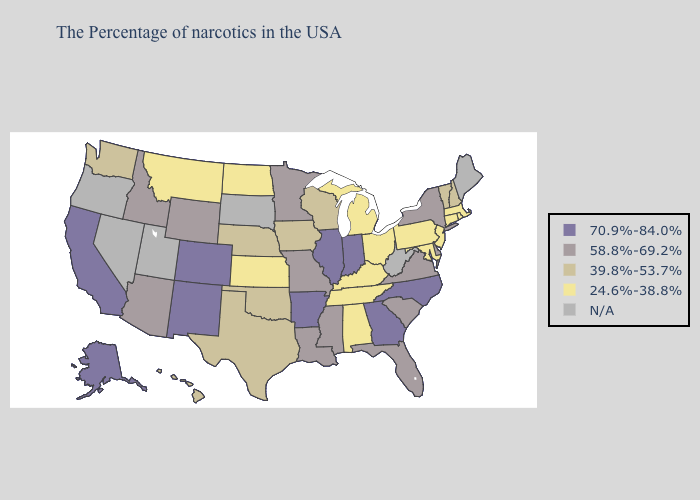Among the states that border Georgia , does South Carolina have the lowest value?
Short answer required. No. What is the highest value in the USA?
Short answer required. 70.9%-84.0%. Does the first symbol in the legend represent the smallest category?
Quick response, please. No. Does Connecticut have the lowest value in the Northeast?
Short answer required. Yes. Does Iowa have the lowest value in the USA?
Answer briefly. No. What is the lowest value in the USA?
Quick response, please. 24.6%-38.8%. What is the value of Oklahoma?
Quick response, please. 39.8%-53.7%. What is the value of California?
Write a very short answer. 70.9%-84.0%. Name the states that have a value in the range 24.6%-38.8%?
Keep it brief. Massachusetts, Rhode Island, Connecticut, New Jersey, Maryland, Pennsylvania, Ohio, Michigan, Kentucky, Alabama, Tennessee, Kansas, North Dakota, Montana. Name the states that have a value in the range 58.8%-69.2%?
Give a very brief answer. New York, Delaware, Virginia, South Carolina, Florida, Mississippi, Louisiana, Missouri, Minnesota, Wyoming, Arizona, Idaho. Among the states that border Florida , does Georgia have the lowest value?
Write a very short answer. No. What is the value of Oklahoma?
Concise answer only. 39.8%-53.7%. Which states have the lowest value in the Northeast?
Keep it brief. Massachusetts, Rhode Island, Connecticut, New Jersey, Pennsylvania. Name the states that have a value in the range N/A?
Short answer required. Maine, West Virginia, South Dakota, Utah, Nevada, Oregon. How many symbols are there in the legend?
Keep it brief. 5. 